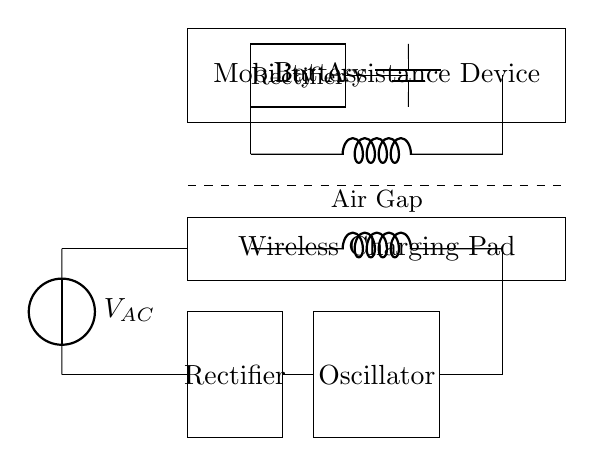What is the primary component of the wireless charging pad? The primary component is the inductor, which is represented in the circuit as a coil. It is responsible for creating a magnetic field for inductive charging.
Answer: inductor What connects the primary coil to the AC source? The primary coil is connected to the AC source through a wire, shown as a single line connecting the source to the coil. This wire allows the AC current to flow into the primary coil.
Answer: wire What is the purpose of the rectifier in the mobility assistance device? The rectifier converts the alternating current from the wireless charging pad into direct current, which can be stored in the battery of the mobility assistance device.
Answer: convert AC to DC How many rectifiers are present in the circuit? There are two rectifiers shown in the circuit: one for the wireless charging pad and one for the mobility assistance device. Each serves to rectify the voltage in its respective part of the circuit.
Answer: 2 What component is used to store energy in the mobility assistance device? The component used to store energy in the mobility assistance device is a battery, which is present in the circuit and is represented as a rectangular symbol.
Answer: battery Why is there an air gap indicated in the circuit? The air gap represents the space between the wireless charging pad and the mobility assistance device's receiving coil. This gap is essential for wireless energy transfer through magnetic induction, reducing interference.
Answer: air gap What type of circuit is represented in this diagram? The circuit represented is a wireless charging circuit, characterized by the use of inductors for energy transfer and rectifiers for converting AC to DC.
Answer: wireless charging circuit 